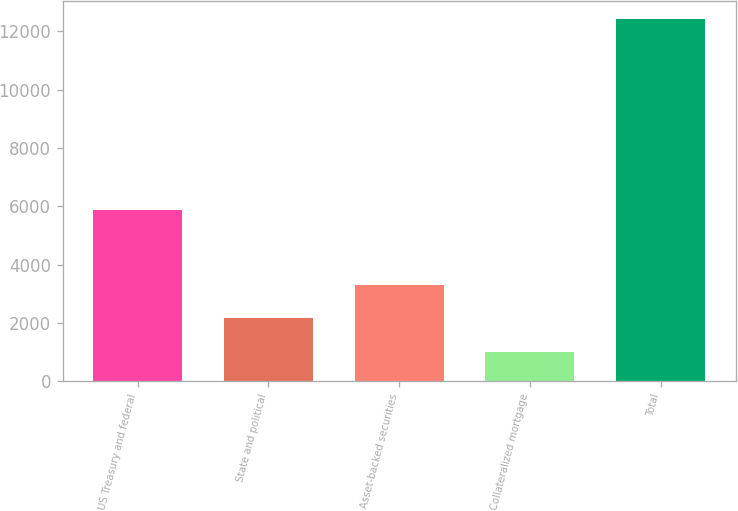<chart> <loc_0><loc_0><loc_500><loc_500><bar_chart><fcel>US Treasury and federal<fcel>State and political<fcel>Asset-backed securities<fcel>Collateralized mortgage<fcel>Total<nl><fcel>5875<fcel>2150.1<fcel>3291.2<fcel>1009<fcel>12420<nl></chart> 